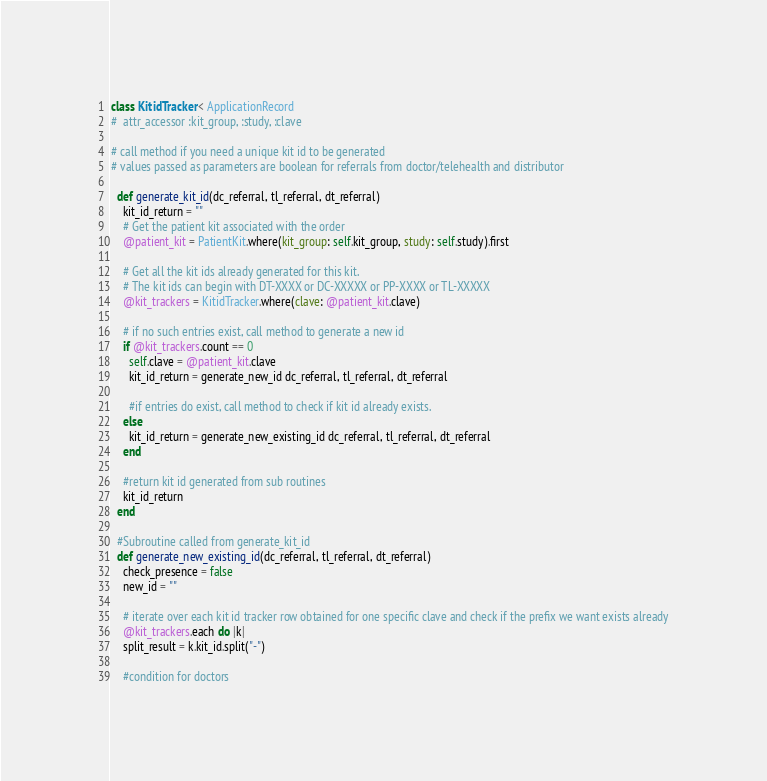Convert code to text. <code><loc_0><loc_0><loc_500><loc_500><_Ruby_>class KitidTracker < ApplicationRecord
#  attr_accessor :kit_group, :study, :clave

# call method if you need a unique kit id to be generated
# values passed as parameters are boolean for referrals from doctor/telehealth and distributor

  def generate_kit_id(dc_referral, tl_referral, dt_referral)
    kit_id_return = ""
    # Get the patient kit associated with the order
    @patient_kit = PatientKit.where(kit_group: self.kit_group, study: self.study).first

    # Get all the kit ids already generated for this kit.
    # The kit ids can begin with DT-XXXX or DC-XXXXX or PP-XXXX or TL-XXXXX
    @kit_trackers = KitidTracker.where(clave: @patient_kit.clave)

    # if no such entries exist, call method to generate a new id
    if @kit_trackers.count == 0
      self.clave = @patient_kit.clave
      kit_id_return = generate_new_id dc_referral, tl_referral, dt_referral

      #if entries do exist, call method to check if kit id already exists.
    else
      kit_id_return = generate_new_existing_id dc_referral, tl_referral, dt_referral
    end

    #return kit id generated from sub routines
    kit_id_return
  end

  #Subroutine called from generate_kit_id
  def generate_new_existing_id(dc_referral, tl_referral, dt_referral)
    check_presence = false
    new_id = ""

    # iterate over each kit id tracker row obtained for one specific clave and check if the prefix we want exists already
    @kit_trackers.each do |k|
    split_result = k.kit_id.split("-")

    #condition for doctors</code> 